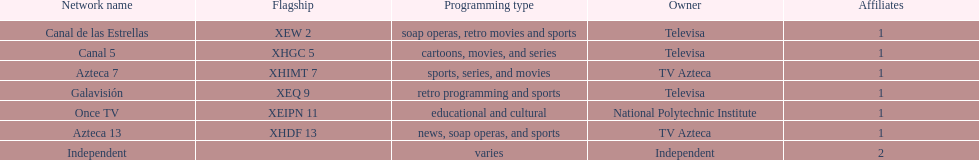What is the average number of affiliates that a given network will have? 1. 